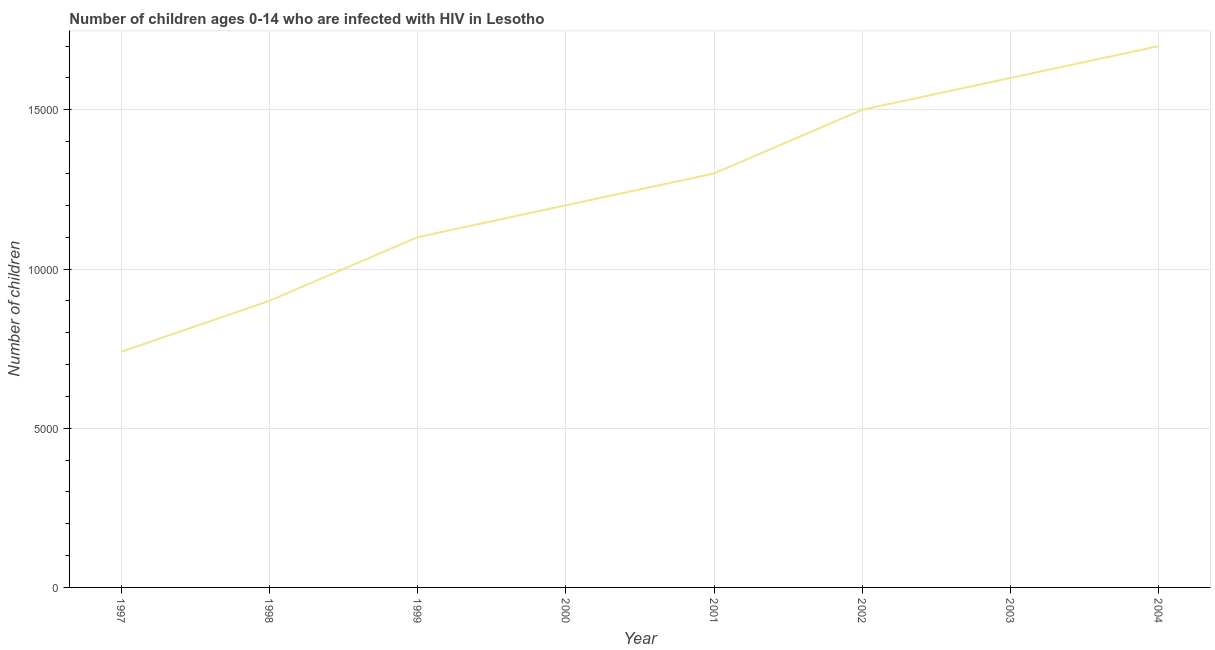What is the number of children living with hiv in 2003?
Give a very brief answer. 1.60e+04. Across all years, what is the maximum number of children living with hiv?
Give a very brief answer. 1.70e+04. Across all years, what is the minimum number of children living with hiv?
Your response must be concise. 7400. What is the sum of the number of children living with hiv?
Your answer should be very brief. 1.00e+05. What is the difference between the number of children living with hiv in 1997 and 1998?
Your answer should be very brief. -1600. What is the average number of children living with hiv per year?
Keep it short and to the point. 1.26e+04. What is the median number of children living with hiv?
Your answer should be compact. 1.25e+04. In how many years, is the number of children living with hiv greater than 15000 ?
Keep it short and to the point. 2. What is the ratio of the number of children living with hiv in 2000 to that in 2001?
Provide a succinct answer. 0.92. Is the number of children living with hiv in 1997 less than that in 1999?
Make the answer very short. Yes. Is the difference between the number of children living with hiv in 2000 and 2003 greater than the difference between any two years?
Your answer should be compact. No. What is the difference between the highest and the lowest number of children living with hiv?
Your response must be concise. 9600. Does the number of children living with hiv monotonically increase over the years?
Make the answer very short. Yes. How many years are there in the graph?
Make the answer very short. 8. Are the values on the major ticks of Y-axis written in scientific E-notation?
Offer a very short reply. No. Does the graph contain any zero values?
Your answer should be very brief. No. Does the graph contain grids?
Give a very brief answer. Yes. What is the title of the graph?
Your answer should be very brief. Number of children ages 0-14 who are infected with HIV in Lesotho. What is the label or title of the X-axis?
Your answer should be compact. Year. What is the label or title of the Y-axis?
Keep it short and to the point. Number of children. What is the Number of children of 1997?
Your answer should be very brief. 7400. What is the Number of children of 1998?
Your answer should be compact. 9000. What is the Number of children in 1999?
Your response must be concise. 1.10e+04. What is the Number of children in 2000?
Give a very brief answer. 1.20e+04. What is the Number of children of 2001?
Keep it short and to the point. 1.30e+04. What is the Number of children in 2002?
Keep it short and to the point. 1.50e+04. What is the Number of children of 2003?
Provide a succinct answer. 1.60e+04. What is the Number of children of 2004?
Offer a very short reply. 1.70e+04. What is the difference between the Number of children in 1997 and 1998?
Keep it short and to the point. -1600. What is the difference between the Number of children in 1997 and 1999?
Your response must be concise. -3600. What is the difference between the Number of children in 1997 and 2000?
Make the answer very short. -4600. What is the difference between the Number of children in 1997 and 2001?
Provide a succinct answer. -5600. What is the difference between the Number of children in 1997 and 2002?
Provide a succinct answer. -7600. What is the difference between the Number of children in 1997 and 2003?
Give a very brief answer. -8600. What is the difference between the Number of children in 1997 and 2004?
Provide a short and direct response. -9600. What is the difference between the Number of children in 1998 and 1999?
Ensure brevity in your answer.  -2000. What is the difference between the Number of children in 1998 and 2000?
Keep it short and to the point. -3000. What is the difference between the Number of children in 1998 and 2001?
Give a very brief answer. -4000. What is the difference between the Number of children in 1998 and 2002?
Provide a short and direct response. -6000. What is the difference between the Number of children in 1998 and 2003?
Keep it short and to the point. -7000. What is the difference between the Number of children in 1998 and 2004?
Offer a very short reply. -8000. What is the difference between the Number of children in 1999 and 2000?
Offer a terse response. -1000. What is the difference between the Number of children in 1999 and 2001?
Offer a terse response. -2000. What is the difference between the Number of children in 1999 and 2002?
Give a very brief answer. -4000. What is the difference between the Number of children in 1999 and 2003?
Your answer should be very brief. -5000. What is the difference between the Number of children in 1999 and 2004?
Give a very brief answer. -6000. What is the difference between the Number of children in 2000 and 2001?
Your response must be concise. -1000. What is the difference between the Number of children in 2000 and 2002?
Make the answer very short. -3000. What is the difference between the Number of children in 2000 and 2003?
Offer a very short reply. -4000. What is the difference between the Number of children in 2000 and 2004?
Offer a terse response. -5000. What is the difference between the Number of children in 2001 and 2002?
Keep it short and to the point. -2000. What is the difference between the Number of children in 2001 and 2003?
Offer a very short reply. -3000. What is the difference between the Number of children in 2001 and 2004?
Your answer should be very brief. -4000. What is the difference between the Number of children in 2002 and 2003?
Your answer should be compact. -1000. What is the difference between the Number of children in 2002 and 2004?
Your answer should be compact. -2000. What is the difference between the Number of children in 2003 and 2004?
Make the answer very short. -1000. What is the ratio of the Number of children in 1997 to that in 1998?
Provide a succinct answer. 0.82. What is the ratio of the Number of children in 1997 to that in 1999?
Provide a short and direct response. 0.67. What is the ratio of the Number of children in 1997 to that in 2000?
Make the answer very short. 0.62. What is the ratio of the Number of children in 1997 to that in 2001?
Your answer should be very brief. 0.57. What is the ratio of the Number of children in 1997 to that in 2002?
Offer a terse response. 0.49. What is the ratio of the Number of children in 1997 to that in 2003?
Offer a very short reply. 0.46. What is the ratio of the Number of children in 1997 to that in 2004?
Provide a succinct answer. 0.43. What is the ratio of the Number of children in 1998 to that in 1999?
Offer a terse response. 0.82. What is the ratio of the Number of children in 1998 to that in 2000?
Give a very brief answer. 0.75. What is the ratio of the Number of children in 1998 to that in 2001?
Keep it short and to the point. 0.69. What is the ratio of the Number of children in 1998 to that in 2003?
Make the answer very short. 0.56. What is the ratio of the Number of children in 1998 to that in 2004?
Give a very brief answer. 0.53. What is the ratio of the Number of children in 1999 to that in 2000?
Give a very brief answer. 0.92. What is the ratio of the Number of children in 1999 to that in 2001?
Your response must be concise. 0.85. What is the ratio of the Number of children in 1999 to that in 2002?
Give a very brief answer. 0.73. What is the ratio of the Number of children in 1999 to that in 2003?
Offer a very short reply. 0.69. What is the ratio of the Number of children in 1999 to that in 2004?
Your answer should be very brief. 0.65. What is the ratio of the Number of children in 2000 to that in 2001?
Offer a very short reply. 0.92. What is the ratio of the Number of children in 2000 to that in 2004?
Keep it short and to the point. 0.71. What is the ratio of the Number of children in 2001 to that in 2002?
Offer a terse response. 0.87. What is the ratio of the Number of children in 2001 to that in 2003?
Offer a very short reply. 0.81. What is the ratio of the Number of children in 2001 to that in 2004?
Provide a short and direct response. 0.77. What is the ratio of the Number of children in 2002 to that in 2003?
Give a very brief answer. 0.94. What is the ratio of the Number of children in 2002 to that in 2004?
Provide a short and direct response. 0.88. What is the ratio of the Number of children in 2003 to that in 2004?
Offer a very short reply. 0.94. 